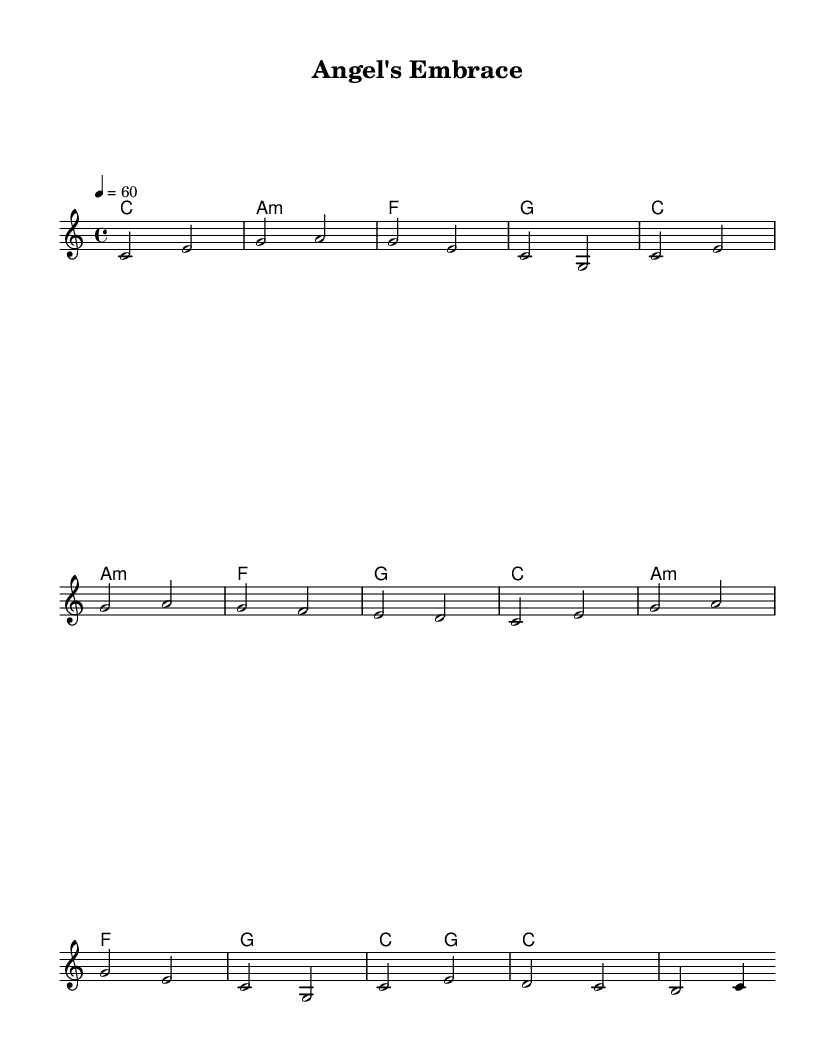What is the key signature of this music? The key signature is indicated in the global section of the code, which specifies the key as C major. C major has no sharps or flats in its signature.
Answer: C major What is the time signature of this piece? The time signature is defined in the global section as 4/4, which means there are four beats in each measure and a quarter note gets one beat.
Answer: 4/4 What is the tempo marking for this piece? The tempo is provided in the global section, indicated as "4 = 60," suggesting that a quarter note gets 60 beats per minute.
Answer: 60 How many measures are in the melody? By counting the notes and breaks in the melody part of the code, we can determine that there are eight measures in total, as indicated by the divisions in phrasing.
Answer: 8 What is the first note of the melody? The melody section starts with a c note, which appears at the beginning of the relative phrase.
Answer: c What chords are used in the first measure? The first measure consists of chord symbols defined in the harmonies section; here, the chords are C major, a minor, and F major.
Answer: C major, A minor, F major What type of song is represented by this music? The overall structure, tempo, and soothing qualities of the melody indicate that this is a lullaby intended to be calming, fitting within the genre of soulful lullabies.
Answer: Lullaby 